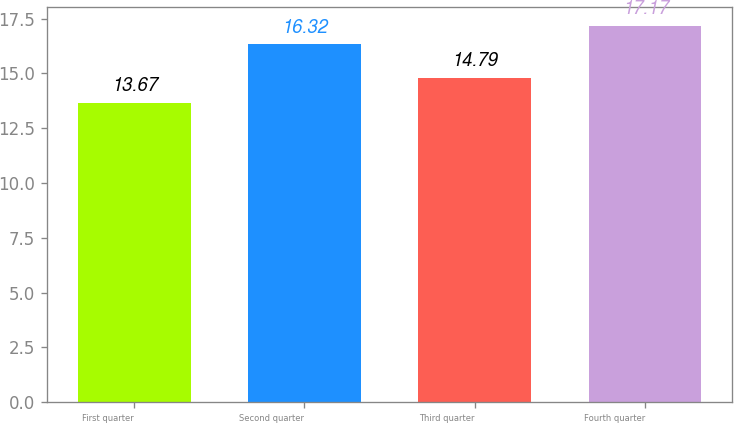Convert chart. <chart><loc_0><loc_0><loc_500><loc_500><bar_chart><fcel>First quarter<fcel>Second quarter<fcel>Third quarter<fcel>Fourth quarter<nl><fcel>13.67<fcel>16.32<fcel>14.79<fcel>17.17<nl></chart> 